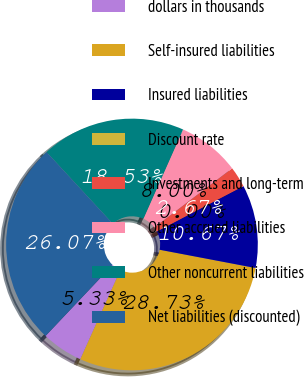Convert chart. <chart><loc_0><loc_0><loc_500><loc_500><pie_chart><fcel>dollars in thousands<fcel>Self-insured liabilities<fcel>Insured liabilities<fcel>Discount rate<fcel>Investments and long-term<fcel>Other accrued liabilities<fcel>Other noncurrent liabilities<fcel>Net liabilities (discounted)<nl><fcel>5.33%<fcel>28.73%<fcel>10.67%<fcel>0.0%<fcel>2.67%<fcel>8.0%<fcel>18.53%<fcel>26.07%<nl></chart> 